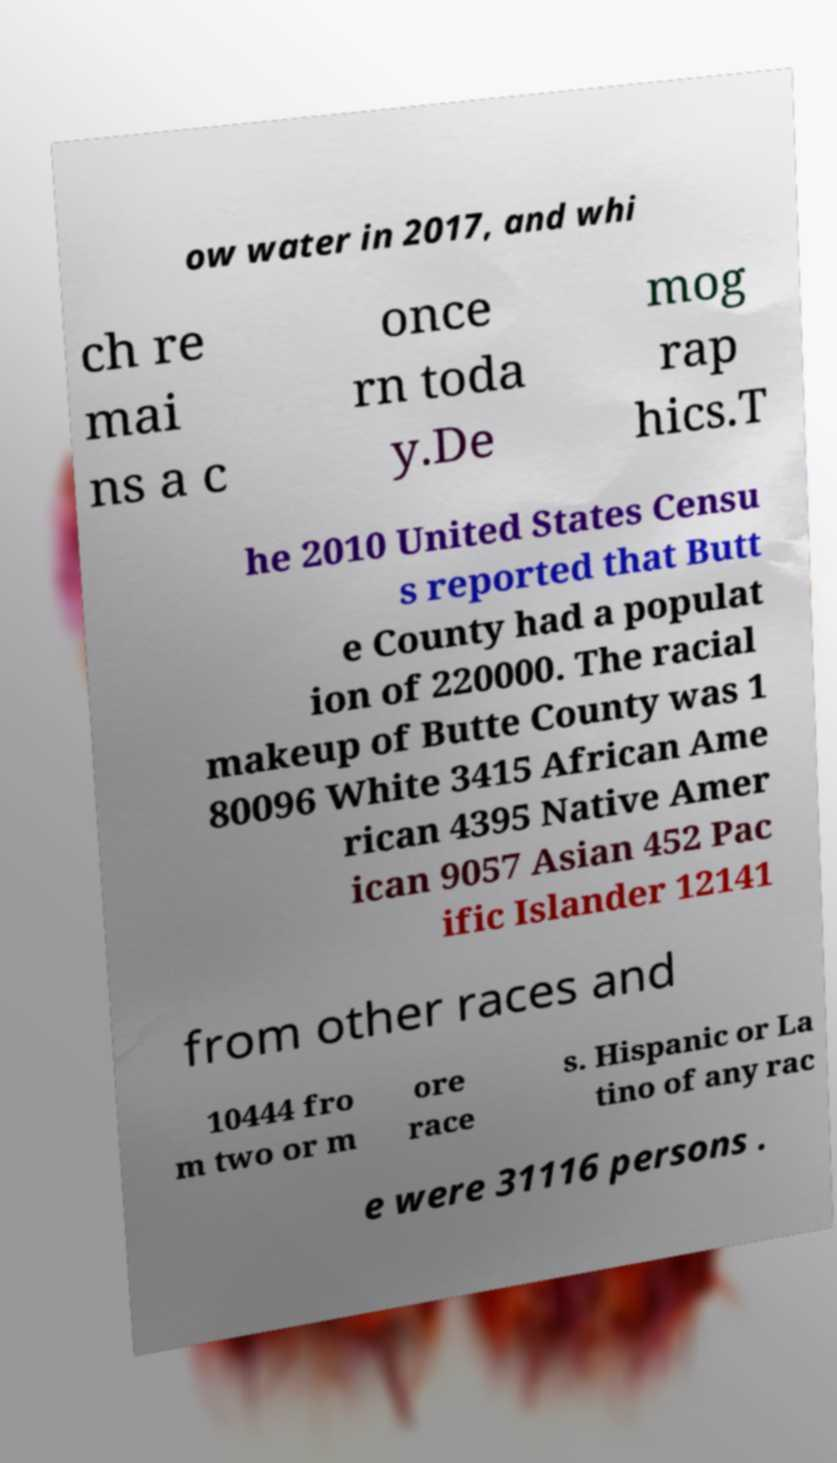Can you read and provide the text displayed in the image?This photo seems to have some interesting text. Can you extract and type it out for me? ow water in 2017, and whi ch re mai ns a c once rn toda y.De mog rap hics.T he 2010 United States Censu s reported that Butt e County had a populat ion of 220000. The racial makeup of Butte County was 1 80096 White 3415 African Ame rican 4395 Native Amer ican 9057 Asian 452 Pac ific Islander 12141 from other races and 10444 fro m two or m ore race s. Hispanic or La tino of any rac e were 31116 persons . 